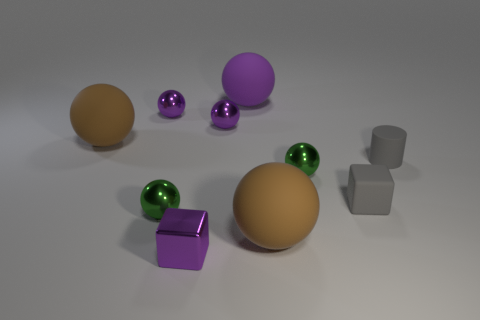Do the green object that is to the right of the purple cube and the big purple thing have the same shape?
Provide a succinct answer. Yes. What number of blocks are the same size as the gray cylinder?
Keep it short and to the point. 2. There is a large matte object that is both in front of the large purple rubber ball and behind the small cylinder; what is its color?
Keep it short and to the point. Brown. Is the number of big blue metal things less than the number of tiny cylinders?
Offer a terse response. Yes. There is a small matte block; is it the same color as the tiny matte cylinder that is right of the rubber cube?
Your answer should be compact. Yes. Are there an equal number of purple metal things to the right of the metallic block and small cylinders right of the purple matte ball?
Your answer should be very brief. Yes. How many tiny gray rubber things are the same shape as the big purple matte thing?
Offer a very short reply. 0. Are any small red cylinders visible?
Your answer should be compact. No. Are the tiny gray cylinder and the large brown sphere on the left side of the big purple thing made of the same material?
Your response must be concise. Yes. There is another cube that is the same size as the purple shiny cube; what is it made of?
Offer a very short reply. Rubber. 